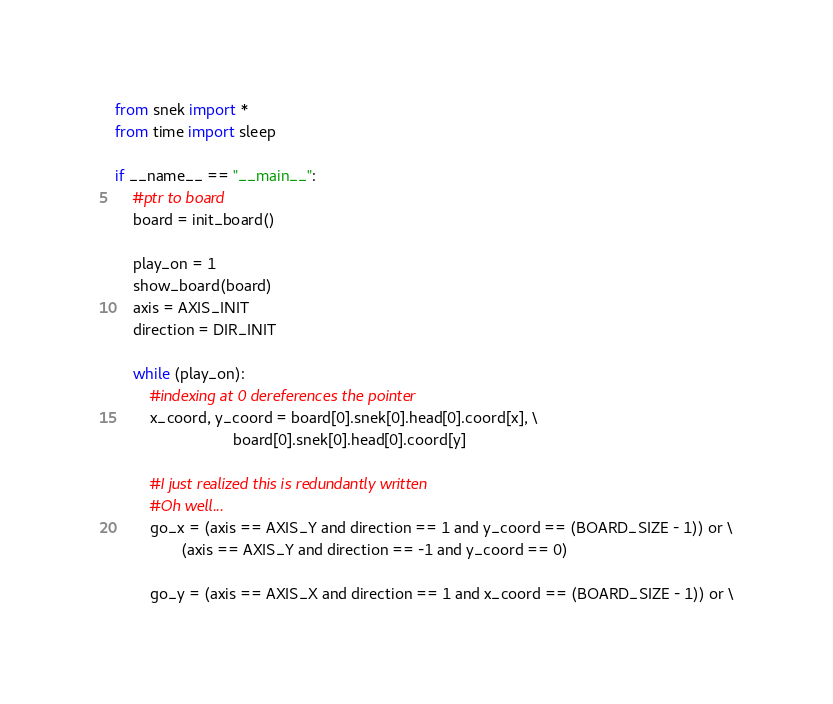<code> <loc_0><loc_0><loc_500><loc_500><_Python_>from snek import *
from time import sleep

if __name__ == "__main__":
	#ptr to board
	board = init_board()
	
	play_on = 1
	show_board(board)
	axis = AXIS_INIT
	direction = DIR_INIT
			
	while (play_on):
		#indexing at 0 dereferences the pointer
		x_coord, y_coord = board[0].snek[0].head[0].coord[x], \
						   board[0].snek[0].head[0].coord[y]
		
		#I just realized this is redundantly written
		#Oh well...
		go_x = (axis == AXIS_Y and direction == 1 and y_coord == (BOARD_SIZE - 1)) or \
			   (axis == AXIS_Y and direction == -1 and y_coord == 0)
		
		go_y = (axis == AXIS_X and direction == 1 and x_coord == (BOARD_SIZE - 1)) or \</code> 